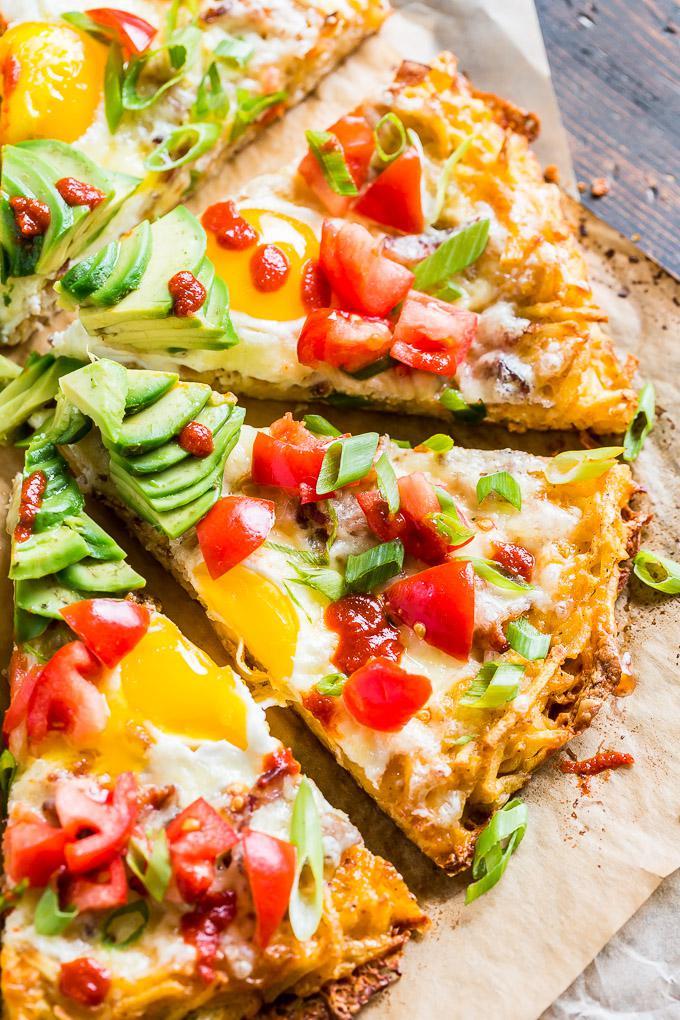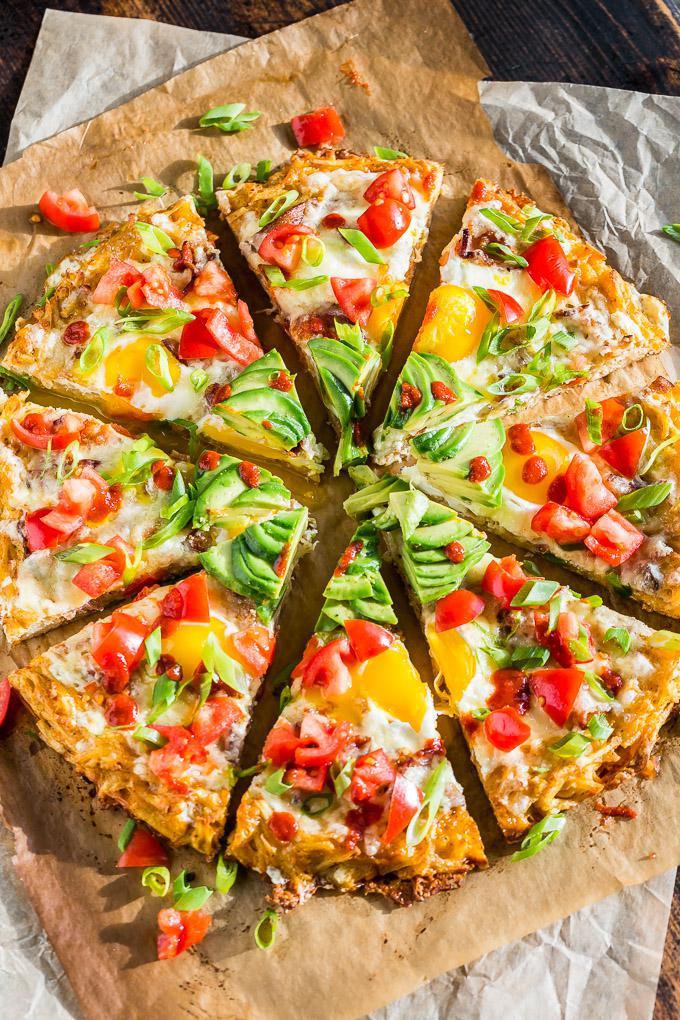The first image is the image on the left, the second image is the image on the right. Assess this claim about the two images: "Both pizzas are cut into slices.". Correct or not? Answer yes or no. Yes. The first image is the image on the left, the second image is the image on the right. For the images displayed, is the sentence "There are two round pizzas and at least one has avocados in the middle of the pizza." factually correct? Answer yes or no. Yes. 